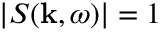<formula> <loc_0><loc_0><loc_500><loc_500>| S ( { k } , \omega ) | = 1</formula> 